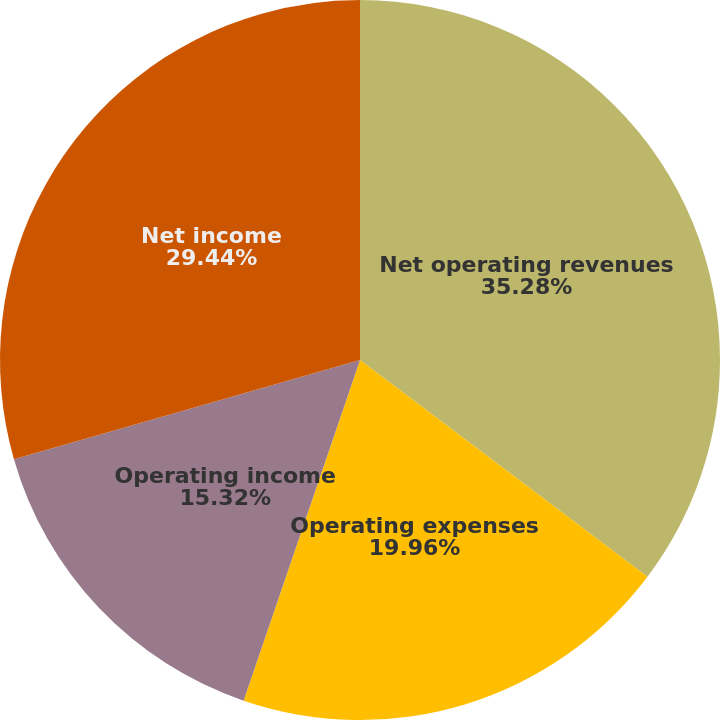Convert chart to OTSL. <chart><loc_0><loc_0><loc_500><loc_500><pie_chart><fcel>Net operating revenues<fcel>Operating expenses<fcel>Operating income<fcel>Net income<nl><fcel>35.28%<fcel>19.96%<fcel>15.32%<fcel>29.44%<nl></chart> 